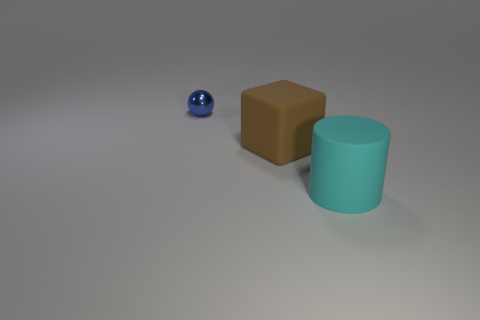Add 2 brown matte things. How many objects exist? 5 Subtract all cylinders. How many objects are left? 2 Subtract 0 cyan spheres. How many objects are left? 3 Subtract all big red balls. Subtract all rubber blocks. How many objects are left? 2 Add 1 big cylinders. How many big cylinders are left? 2 Add 2 purple rubber spheres. How many purple rubber spheres exist? 2 